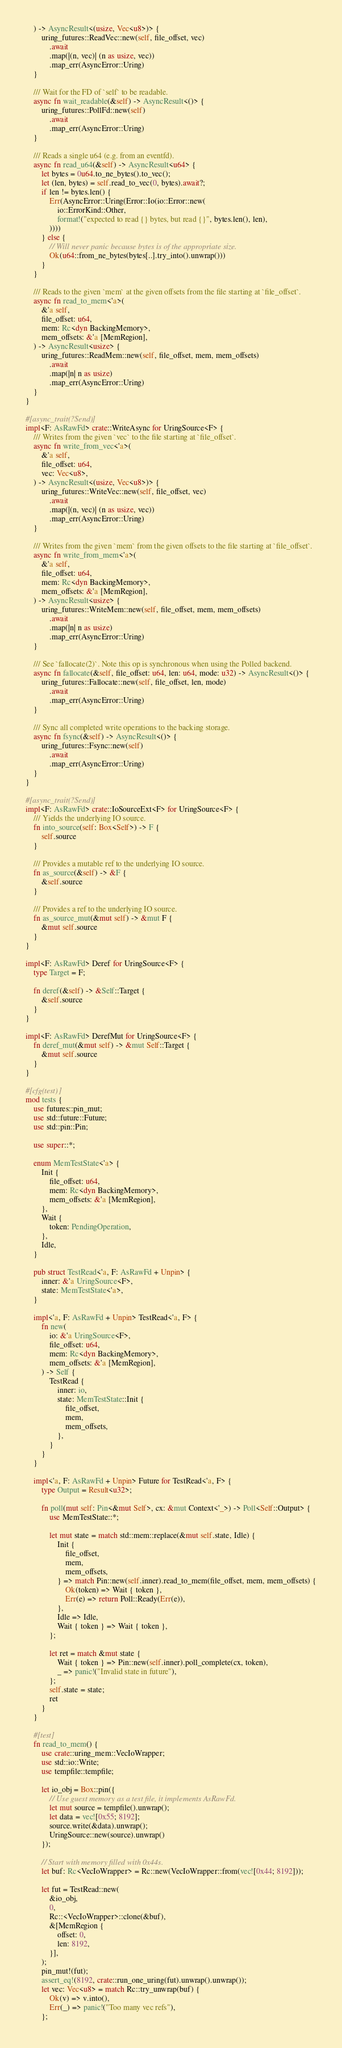Convert code to text. <code><loc_0><loc_0><loc_500><loc_500><_Rust_>    ) -> AsyncResult<(usize, Vec<u8>)> {
        uring_futures::ReadVec::new(self, file_offset, vec)
            .await
            .map(|(n, vec)| (n as usize, vec))
            .map_err(AsyncError::Uring)
    }

    /// Wait for the FD of `self` to be readable.
    async fn wait_readable(&self) -> AsyncResult<()> {
        uring_futures::PollFd::new(self)
            .await
            .map_err(AsyncError::Uring)
    }

    /// Reads a single u64 (e.g. from an eventfd).
    async fn read_u64(&self) -> AsyncResult<u64> {
        let bytes = 0u64.to_ne_bytes().to_vec();
        let (len, bytes) = self.read_to_vec(0, bytes).await?;
        if len != bytes.len() {
            Err(AsyncError::Uring(Error::Io(io::Error::new(
                io::ErrorKind::Other,
                format!("expected to read {} bytes, but read {}", bytes.len(), len),
            ))))
        } else {
            // Will never panic because bytes is of the appropriate size.
            Ok(u64::from_ne_bytes(bytes[..].try_into().unwrap()))
        }
    }

    /// Reads to the given `mem` at the given offsets from the file starting at `file_offset`.
    async fn read_to_mem<'a>(
        &'a self,
        file_offset: u64,
        mem: Rc<dyn BackingMemory>,
        mem_offsets: &'a [MemRegion],
    ) -> AsyncResult<usize> {
        uring_futures::ReadMem::new(self, file_offset, mem, mem_offsets)
            .await
            .map(|n| n as usize)
            .map_err(AsyncError::Uring)
    }
}

#[async_trait(?Send)]
impl<F: AsRawFd> crate::WriteAsync for UringSource<F> {
    /// Writes from the given `vec` to the file starting at `file_offset`.
    async fn write_from_vec<'a>(
        &'a self,
        file_offset: u64,
        vec: Vec<u8>,
    ) -> AsyncResult<(usize, Vec<u8>)> {
        uring_futures::WriteVec::new(self, file_offset, vec)
            .await
            .map(|(n, vec)| (n as usize, vec))
            .map_err(AsyncError::Uring)
    }

    /// Writes from the given `mem` from the given offsets to the file starting at `file_offset`.
    async fn write_from_mem<'a>(
        &'a self,
        file_offset: u64,
        mem: Rc<dyn BackingMemory>,
        mem_offsets: &'a [MemRegion],
    ) -> AsyncResult<usize> {
        uring_futures::WriteMem::new(self, file_offset, mem, mem_offsets)
            .await
            .map(|n| n as usize)
            .map_err(AsyncError::Uring)
    }

    /// See `fallocate(2)`. Note this op is synchronous when using the Polled backend.
    async fn fallocate(&self, file_offset: u64, len: u64, mode: u32) -> AsyncResult<()> {
        uring_futures::Fallocate::new(self, file_offset, len, mode)
            .await
            .map_err(AsyncError::Uring)
    }

    /// Sync all completed write operations to the backing storage.
    async fn fsync(&self) -> AsyncResult<()> {
        uring_futures::Fsync::new(self)
            .await
            .map_err(AsyncError::Uring)
    }
}

#[async_trait(?Send)]
impl<F: AsRawFd> crate::IoSourceExt<F> for UringSource<F> {
    /// Yields the underlying IO source.
    fn into_source(self: Box<Self>) -> F {
        self.source
    }

    /// Provides a mutable ref to the underlying IO source.
    fn as_source(&self) -> &F {
        &self.source
    }

    /// Provides a ref to the underlying IO source.
    fn as_source_mut(&mut self) -> &mut F {
        &mut self.source
    }
}

impl<F: AsRawFd> Deref for UringSource<F> {
    type Target = F;

    fn deref(&self) -> &Self::Target {
        &self.source
    }
}

impl<F: AsRawFd> DerefMut for UringSource<F> {
    fn deref_mut(&mut self) -> &mut Self::Target {
        &mut self.source
    }
}

#[cfg(test)]
mod tests {
    use futures::pin_mut;
    use std::future::Future;
    use std::pin::Pin;

    use super::*;

    enum MemTestState<'a> {
        Init {
            file_offset: u64,
            mem: Rc<dyn BackingMemory>,
            mem_offsets: &'a [MemRegion],
        },
        Wait {
            token: PendingOperation,
        },
        Idle,
    }

    pub struct TestRead<'a, F: AsRawFd + Unpin> {
        inner: &'a UringSource<F>,
        state: MemTestState<'a>,
    }

    impl<'a, F: AsRawFd + Unpin> TestRead<'a, F> {
        fn new(
            io: &'a UringSource<F>,
            file_offset: u64,
            mem: Rc<dyn BackingMemory>,
            mem_offsets: &'a [MemRegion],
        ) -> Self {
            TestRead {
                inner: io,
                state: MemTestState::Init {
                    file_offset,
                    mem,
                    mem_offsets,
                },
            }
        }
    }

    impl<'a, F: AsRawFd + Unpin> Future for TestRead<'a, F> {
        type Output = Result<u32>;

        fn poll(mut self: Pin<&mut Self>, cx: &mut Context<'_>) -> Poll<Self::Output> {
            use MemTestState::*;

            let mut state = match std::mem::replace(&mut self.state, Idle) {
                Init {
                    file_offset,
                    mem,
                    mem_offsets,
                } => match Pin::new(self.inner).read_to_mem(file_offset, mem, mem_offsets) {
                    Ok(token) => Wait { token },
                    Err(e) => return Poll::Ready(Err(e)),
                },
                Idle => Idle,
                Wait { token } => Wait { token },
            };

            let ret = match &mut state {
                Wait { token } => Pin::new(self.inner).poll_complete(cx, token),
                _ => panic!("Invalid state in future"),
            };
            self.state = state;
            ret
        }
    }

    #[test]
    fn read_to_mem() {
        use crate::uring_mem::VecIoWrapper;
        use std::io::Write;
        use tempfile::tempfile;

        let io_obj = Box::pin({
            // Use guest memory as a test file, it implements AsRawFd.
            let mut source = tempfile().unwrap();
            let data = vec![0x55; 8192];
            source.write(&data).unwrap();
            UringSource::new(source).unwrap()
        });

        // Start with memory filled with 0x44s.
        let buf: Rc<VecIoWrapper> = Rc::new(VecIoWrapper::from(vec![0x44; 8192]));

        let fut = TestRead::new(
            &io_obj,
            0,
            Rc::<VecIoWrapper>::clone(&buf),
            &[MemRegion {
                offset: 0,
                len: 8192,
            }],
        );
        pin_mut!(fut);
        assert_eq!(8192, crate::run_one_uring(fut).unwrap().unwrap());
        let vec: Vec<u8> = match Rc::try_unwrap(buf) {
            Ok(v) => v.into(),
            Err(_) => panic!("Too many vec refs"),
        };</code> 